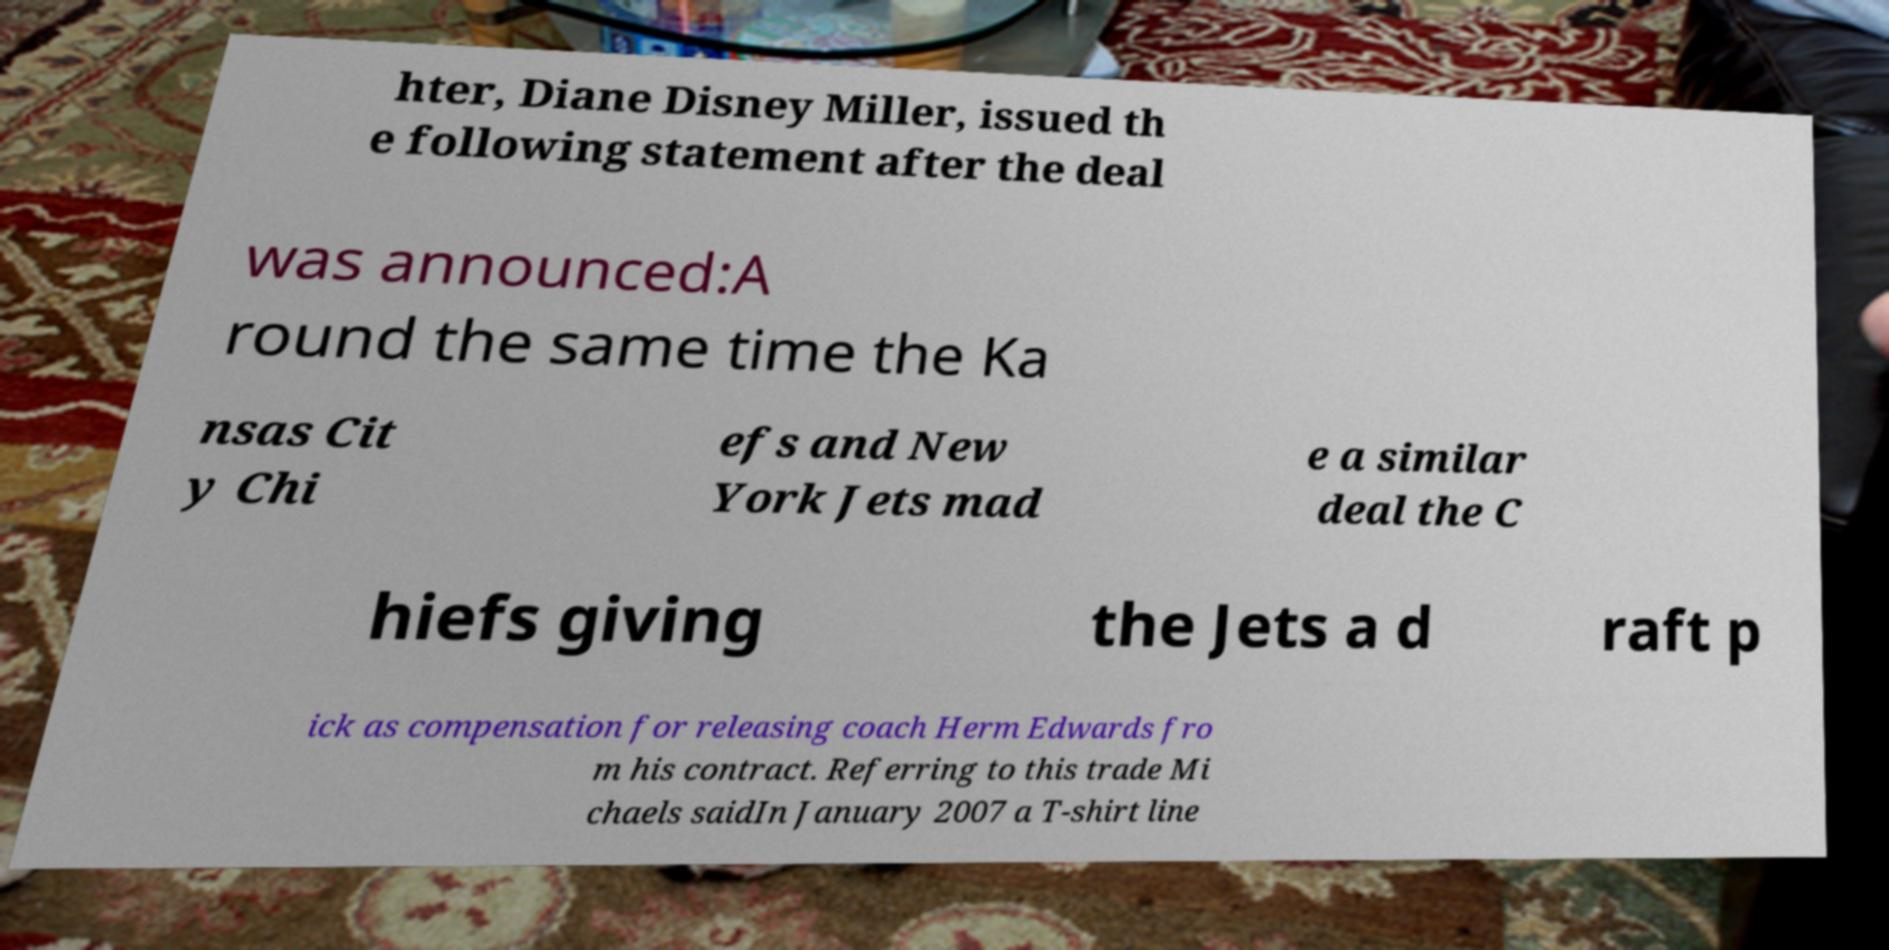Can you read and provide the text displayed in the image?This photo seems to have some interesting text. Can you extract and type it out for me? hter, Diane Disney Miller, issued th e following statement after the deal was announced:A round the same time the Ka nsas Cit y Chi efs and New York Jets mad e a similar deal the C hiefs giving the Jets a d raft p ick as compensation for releasing coach Herm Edwards fro m his contract. Referring to this trade Mi chaels saidIn January 2007 a T-shirt line 